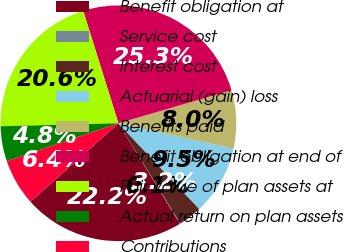Convert chart to OTSL. <chart><loc_0><loc_0><loc_500><loc_500><pie_chart><fcel>Benefit obligation at<fcel>Service cost<fcel>Interest cost<fcel>Actuarial (gain) loss<fcel>Benefits paid<fcel>Benefit obligation at end of<fcel>Fair value of plan assets at<fcel>Actual return on plan assets<fcel>Contributions<nl><fcel>22.16%<fcel>0.07%<fcel>3.22%<fcel>9.53%<fcel>7.96%<fcel>25.31%<fcel>20.58%<fcel>4.8%<fcel>6.38%<nl></chart> 